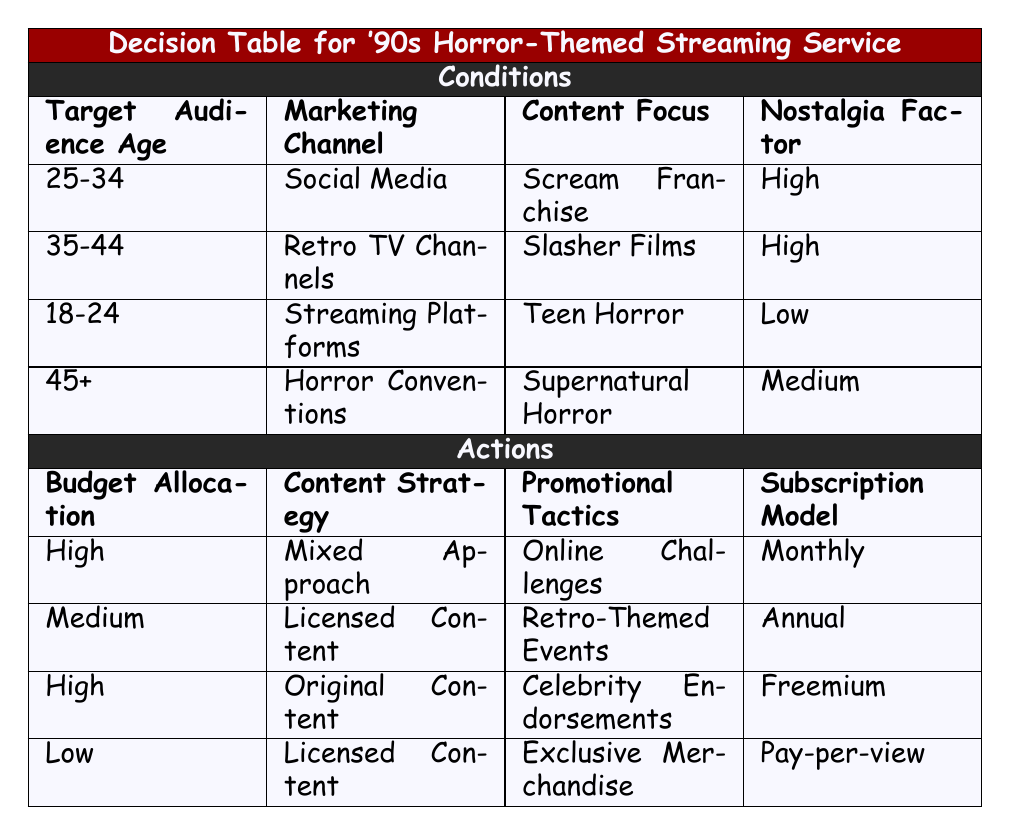What is the budget allocation for the 18-24 age group? The 18-24 age group is associated with the Streaming Platforms marketing channel, with a focus on Teen Horror and a low nostalgia factor. According to the table, the budget allocation for this group is High.
Answer: High Which marketing channel is suggested for the 25-34 age group? The table indicates that for the 25-34 age group, the recommended marketing channel is Social Media.
Answer: Social Media Is the nostalgic factor for the 35-44 age group high? The condition for the 35-44 age group shows that the nostalgia factor is categorized as High according to the table. Therefore, the answer is yes.
Answer: Yes How does the content strategy differ between the 25-34 and 45+ age groups? For the 25-34 age group, the content strategy is a Mixed Approach. For the 45+ age group, it is Licensed Content. This shows a difference in strategy focusing on various content types based on the target audience.
Answer: Mixed Approach vs. Licensed Content What would be the promotional tactic for the audience aged 45 and over? The table lists that for the audience aged 45+, the suggested promotional tactic is Exclusive Merchandise.
Answer: Exclusive Merchandise What is the average budget allocation for all age groups listed? The budget allocations for the groups are High, Medium, High, and Low, which translates to a numerical equivalent of 3, 2, 3, and 1 (on a scale where High=3, Medium=2, Low=1). The total is 3 + 2 + 3 + 1 = 9, and with 4 groups, the average budget allocation is 9/4 = 2.25, which statistically corresponds to a Medium allocation.
Answer: Medium Is the subscription model for the target audience aged 25-34 monthly? According to the table, the subscription model for the 25-34 age group is indeed Monthly. Therefore, the answer is yes.
Answer: Yes Which content focus is associated with the highest budget allocation? The budget allocation for the 25-34 age group is High with a focus on the Scream Franchise and mixed approach content strategy, making it the highest budget allocation association in the table.
Answer: Scream Franchise What promotional tactic is least expensive based on the budget allocation for the 45+ age group? The budget allocation for the 45+ age group is Low, and the associated promotional tactic is Exclusive Merchandise, which can be considered the least expensive option when budgeted.
Answer: Exclusive Merchandise 